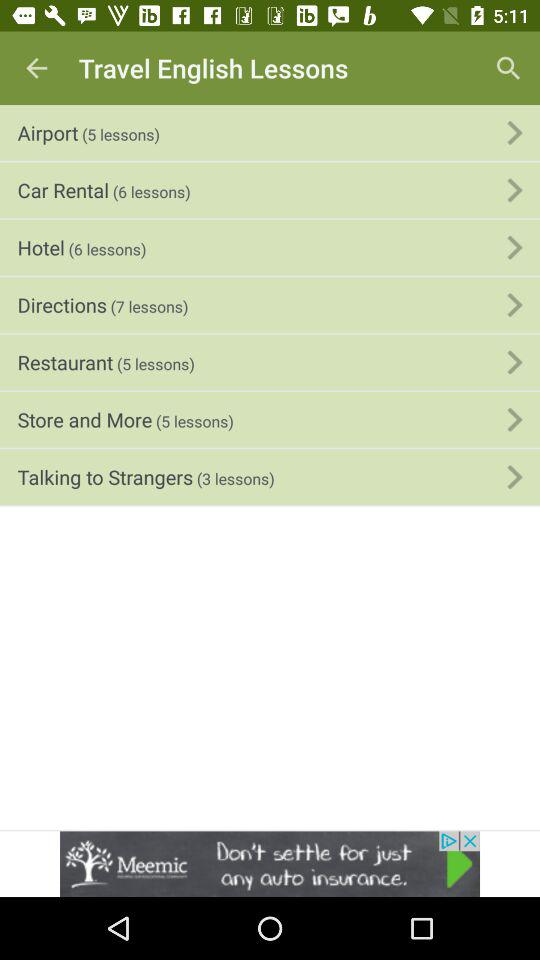How many lessons are in the Store and More section? The Store and More section contains 5 lessons. This section is part of a collection of Travel English Lessons designed to help learners navigate various common travel-related situations. 